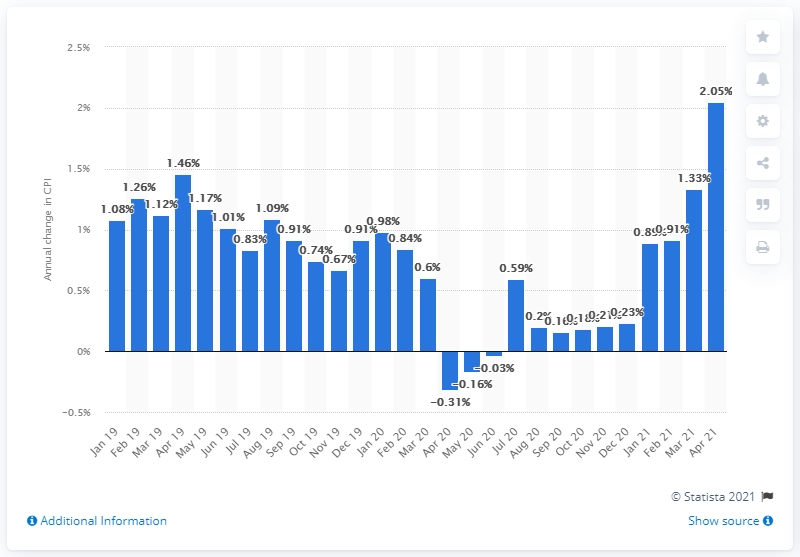Indicate a few pertinent items in this graphic. The change in consumer prices in April 2021 was 2.05%. 